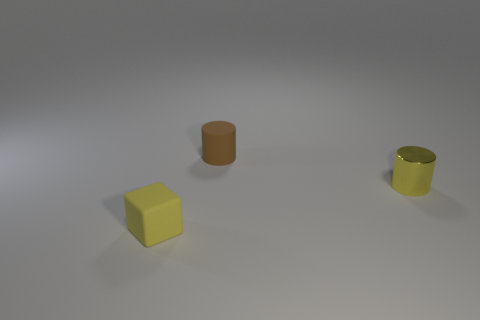Can you tell me the colors of the objects present in the image? Certainly! In the image, there are three objects, each with a distinct color. There's a yellow cube, a brown cylinder, and a yellow cylinder which appears to have a metallic sheen contrasted with the matte finish of the other objects. 